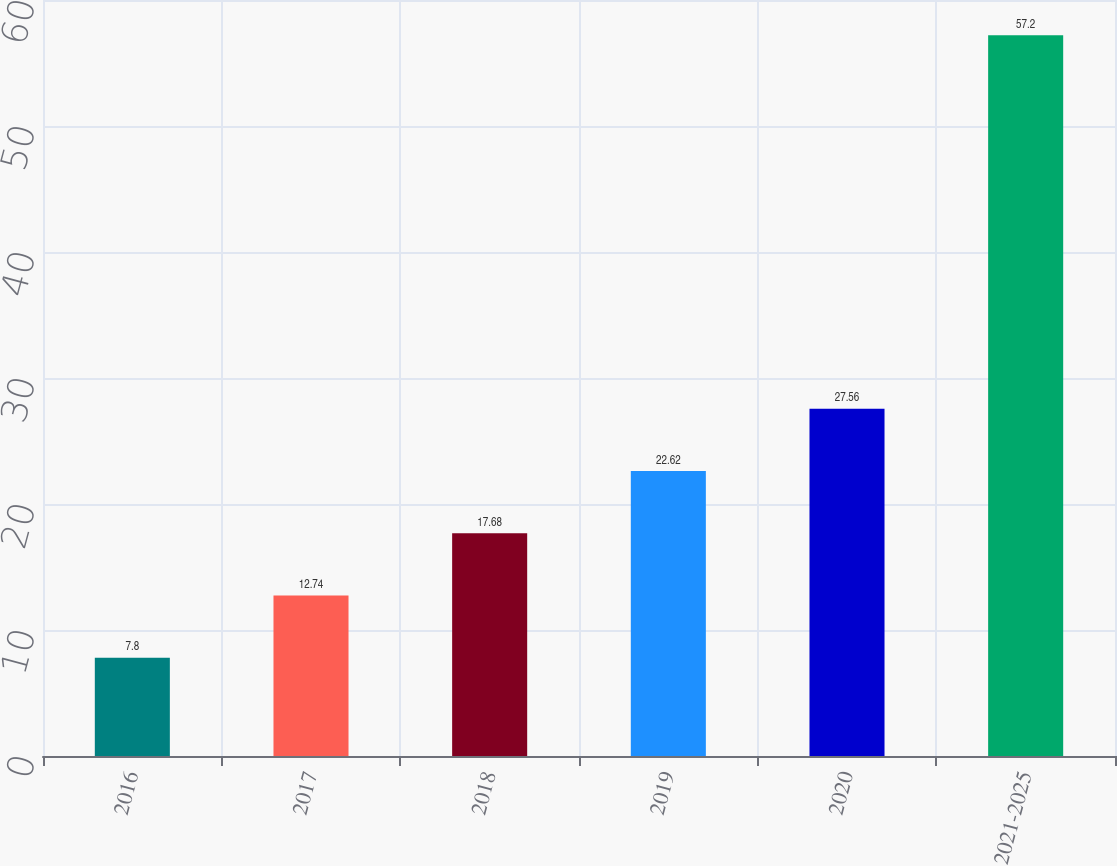Convert chart to OTSL. <chart><loc_0><loc_0><loc_500><loc_500><bar_chart><fcel>2016<fcel>2017<fcel>2018<fcel>2019<fcel>2020<fcel>2021-2025<nl><fcel>7.8<fcel>12.74<fcel>17.68<fcel>22.62<fcel>27.56<fcel>57.2<nl></chart> 